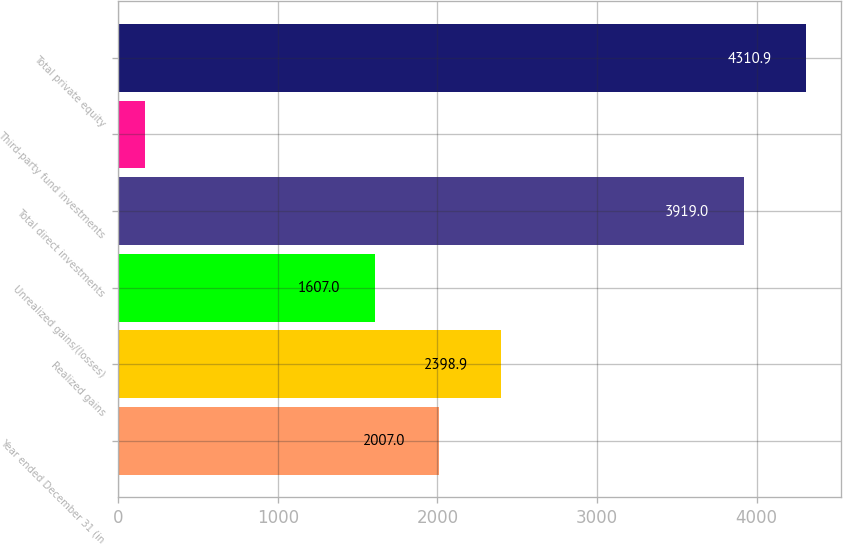<chart> <loc_0><loc_0><loc_500><loc_500><bar_chart><fcel>Year ended December 31 (in<fcel>Realized gains<fcel>Unrealized gains/(losses)<fcel>Total direct investments<fcel>Third-party fund investments<fcel>Total private equity<nl><fcel>2007<fcel>2398.9<fcel>1607<fcel>3919<fcel>165<fcel>4310.9<nl></chart> 